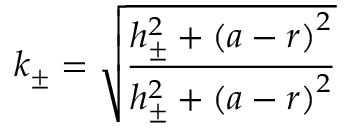Convert formula to latex. <formula><loc_0><loc_0><loc_500><loc_500>k _ { \pm } = \sqrt { \frac { h _ { \pm } ^ { 2 } + \left ( a - r \right ) ^ { 2 } } { h _ { \pm } ^ { 2 } + \left ( a - r \right ) ^ { 2 } } }</formula> 